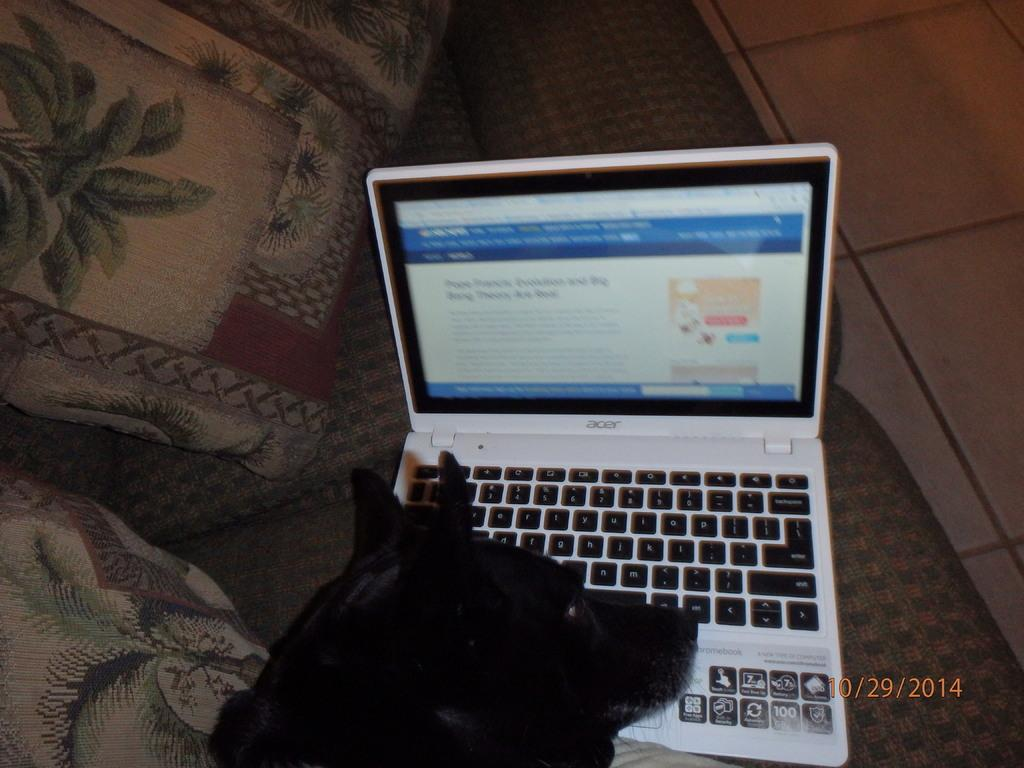<image>
Render a clear and concise summary of the photo. a dog's head on a computer lap top with date imprint of 10/29/2014 